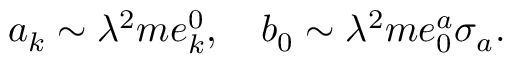<formula> <loc_0><loc_0><loc_500><loc_500>a _ { k } \sim \lambda ^ { 2 } m e _ { k } ^ { 0 } , b _ { 0 } \sim \lambda ^ { 2 } m e _ { 0 } ^ { a } \sigma _ { a } .</formula> 